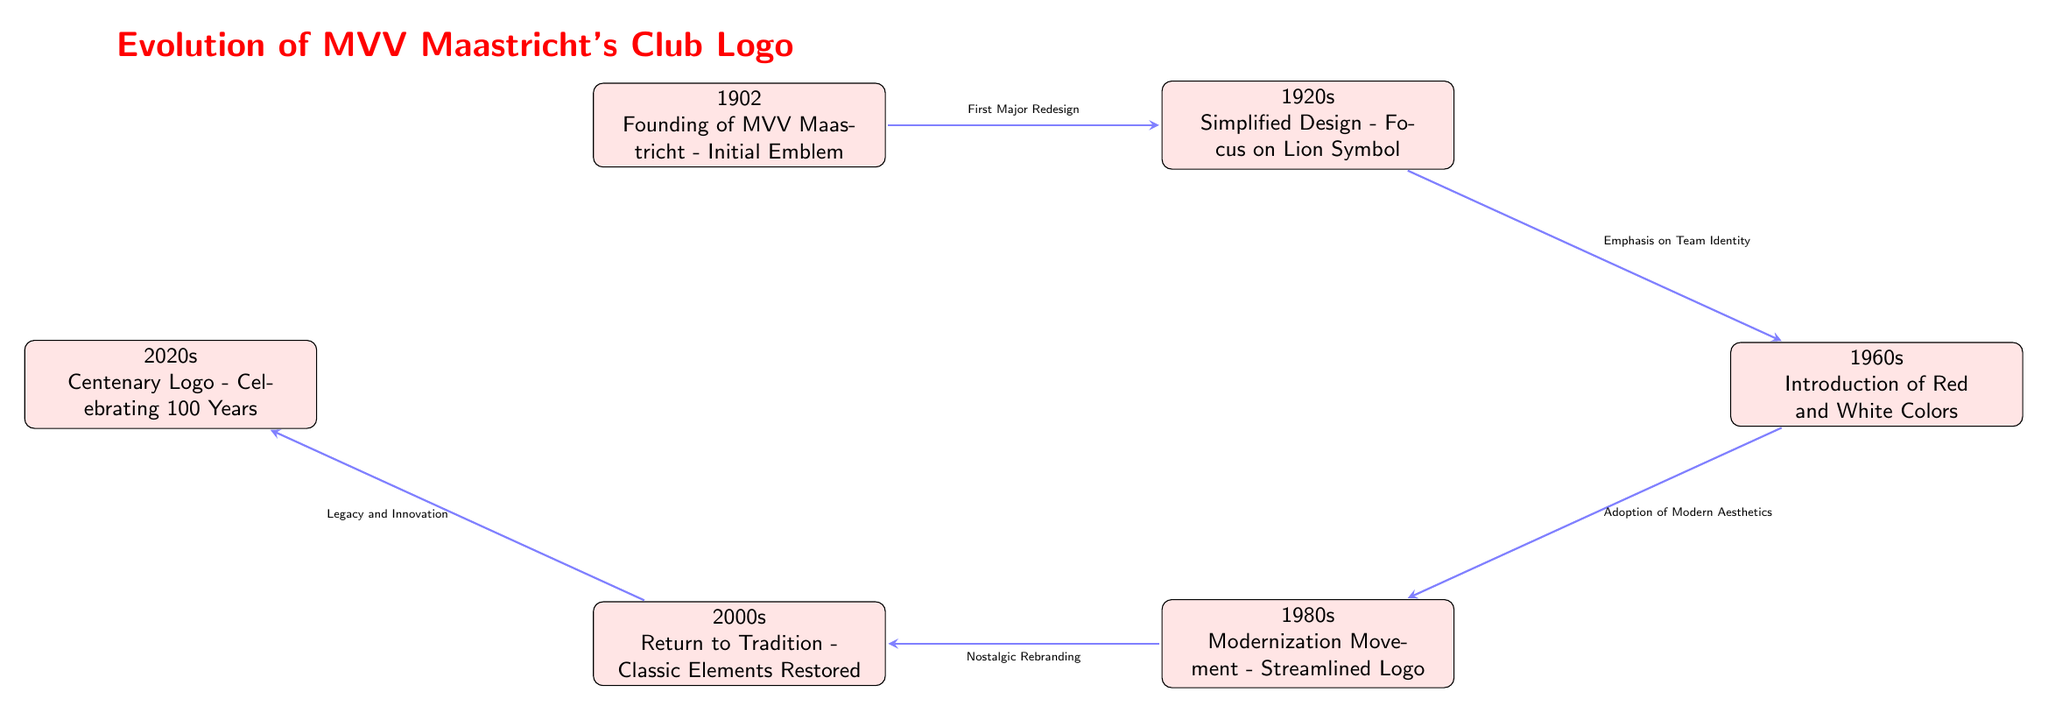What year did MVV Maastricht get founded? The founding year of MVV Maastricht is specified directly at the top left node of the diagram. It states "1902" as the initial emblem in the context of the club's establishment.
Answer: 1902 What color scheme was introduced in the 1960s? The node representing the 1960s indicates the introduction of "Red and White Colors," which directly answers the question regarding the color scheme.
Answer: Red and White Which decade features the restoration of classic elements in the logo? In the diagram, the node for the 2000s specifically mentions "Return to Tradition - Classic Elements Restored," indicating this decade is focused on classic elements.
Answer: 2000s What is the last year mentioned in the evolution of the club logo? The last node at the bottom right of the diagram refers to the 2020s, denoting the centenary logo, making this the most recent year presented.
Answer: 2020s What significant design change occurred in the 1920s? The transition arrow coming from the 1920s node mentions "Emphasis on Team Identity," which signifies a major design change focused on enhancing the team's representation through its logo.
Answer: Emphasis on Team Identity Which decade connects the introduction of modern aesthetics to nostalgic rebranding? The transition from the 1960s to the 1980s node directly indicates the link between "Adoption of Modern Aesthetics" and "Nostalgic Rebranding." Thus, the 1980s directly relates to this connection.
Answer: 1980s How many main nodes are displayed in the diagram? The main nodes represent key design elements over the decades and include five distinct nodes from 1902 to 2020s, which total the number of main events depicted in the evolution.
Answer: 6 What major redesign took place first in the logo evolution? The arrow pointing from the 1902 node to the 1920 node indicates that the "First Major Redesign" occurred transitioning from the founding emblem to the simplified design.
Answer: First Major Redesign What concept is emphasized in the 1980s logo evolution? The 1980s node states "Modernization Movement - Streamlined Logo," which clearly indicates that this decade's focus was on modernizing and simplifying the logo's design.
Answer: Modernization Movement 